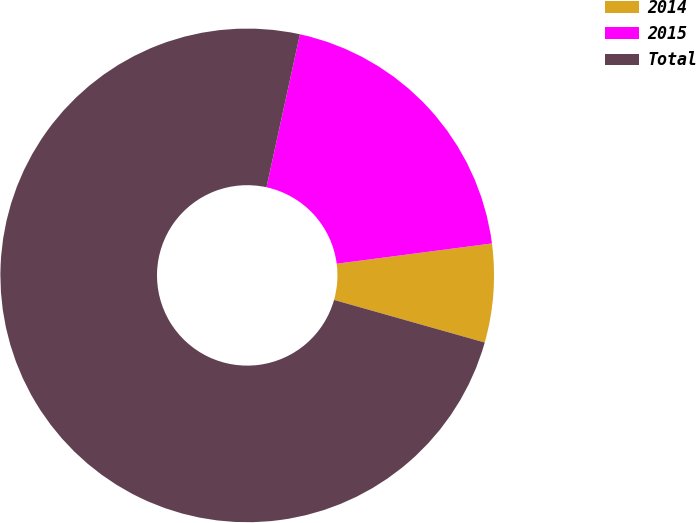<chart> <loc_0><loc_0><loc_500><loc_500><pie_chart><fcel>2014<fcel>2015<fcel>Total<nl><fcel>6.45%<fcel>19.51%<fcel>74.04%<nl></chart> 